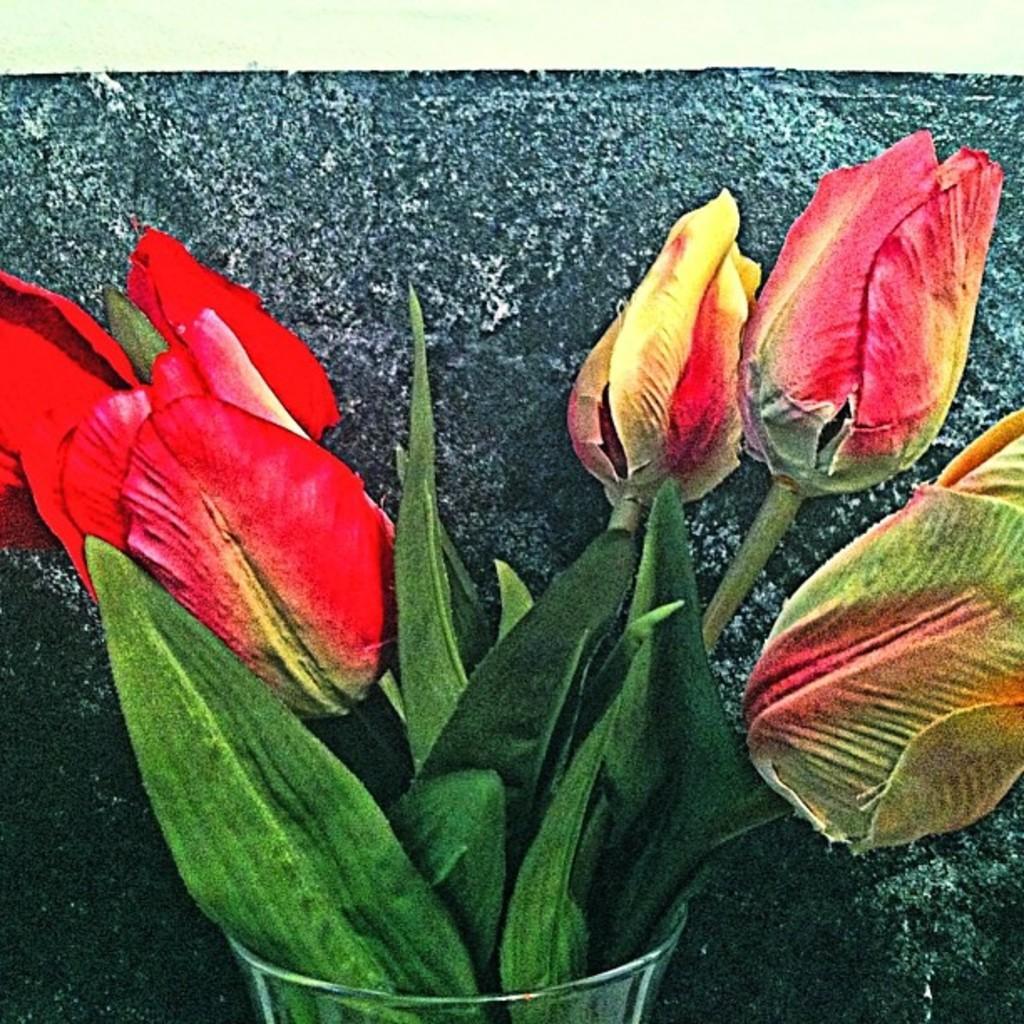Describe this image in one or two sentences. In this image we can see some flowers and leaves in an object, which looks like a glass and in the background we can see the wall. 